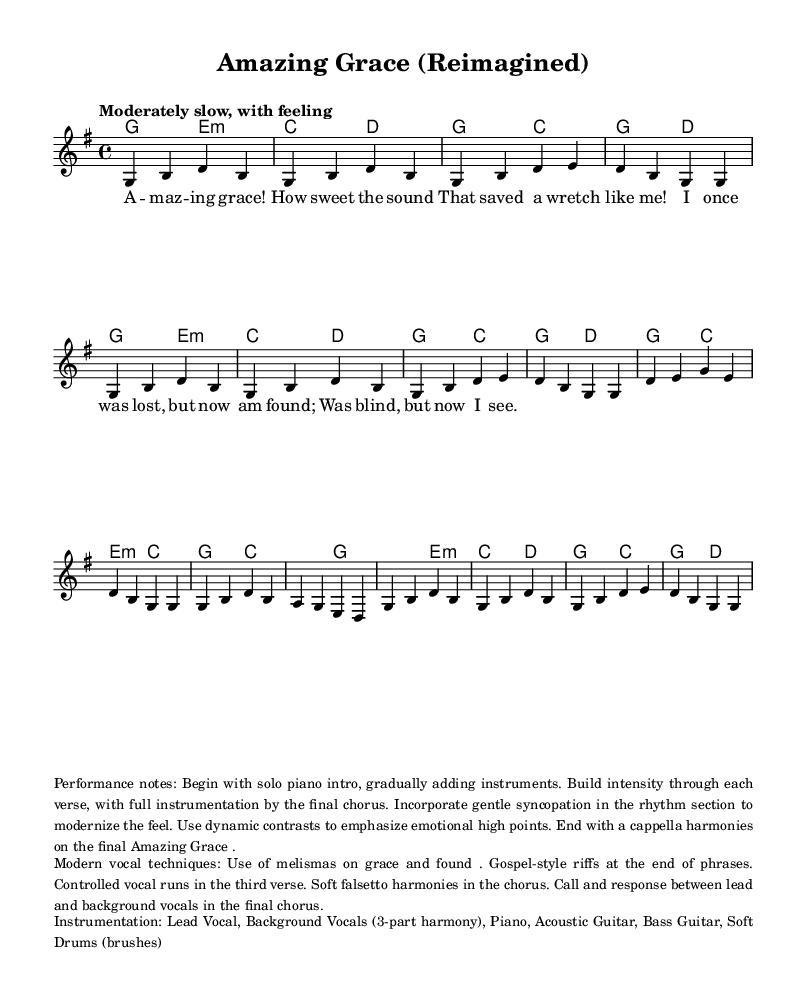What is the key signature of this music? The key signature is G major, which includes one sharp, F#. This can be determined by looking at the clef and the key signature indicator at the beginning of the staff.
Answer: G major What is the time signature of this piece? The time signature indicates that there are four beats per measure, which is denoted by the 4/4 at the beginning of the score. This is a common time signature for many hymns.
Answer: 4/4 What is the tempo marking of this piece? The tempo marking is indicated as "Moderately slow, with feeling" in the score, which provides a qualitative description of the desired speed of the music.
Answer: Moderately slow, with feeling How many verses does the piece include? Upon reviewing the lyrics in the score, it is clear that there are four lines of lyrics present, indicating four significant phrases typically relating to the verses.
Answer: Four What modern vocal techniques are incorporated in this arrangement? The techniques listed include melismas, gospel-style riffs, controlled vocal runs, soft falsetto harmonies, and call and response, making it a modern interpretation of a traditional hymn.
Answer: Melismas, gospel-style riffs, controlled vocal runs, soft falsetto harmonies, call and response What instruments are used in the instrumentation? The instrumentation section details the use of lead vocal, background vocals, piano, acoustic guitar, bass guitar, and soft drums, which collectively create a rich sound for the hymn.
Answer: Lead Vocal, Background Vocals, Piano, Acoustic Guitar, Bass Guitar, Soft Drums What are the performance notes for this arrangement? The performance notes suggest starting with a solo piano intro, gradually adding instruments and building intensity, highlighting emotional high points, and concluding with a cappella harmonies.
Answer: Solo piano intro, build intensity, a cappella harmonies 